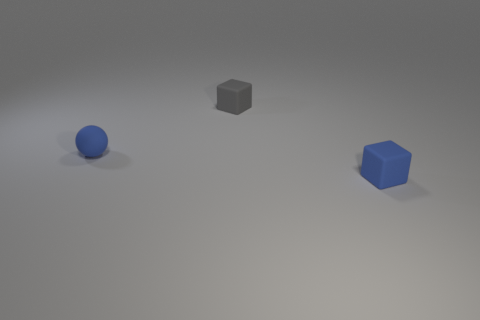Is there anything else that has the same material as the blue ball?
Your response must be concise. Yes. There is a thing that is in front of the tiny gray rubber block and on the right side of the small matte sphere; what is its material?
Give a very brief answer. Rubber. How many other gray objects are the same shape as the tiny gray thing?
Your answer should be very brief. 0. There is a sphere that is left of the block that is in front of the rubber ball; what color is it?
Make the answer very short. Blue. Are there the same number of things that are behind the small blue cube and rubber spheres?
Keep it short and to the point. No. Is there another matte thing that has the same size as the gray thing?
Keep it short and to the point. Yes. There is a blue matte block; is its size the same as the matte thing that is to the left of the small gray rubber object?
Offer a very short reply. Yes. Are there an equal number of blue balls that are in front of the small blue rubber ball and tiny things that are behind the tiny gray block?
Your answer should be compact. Yes. There is a gray cube that is on the left side of the small blue cube; what is it made of?
Your response must be concise. Rubber. Do the gray matte cube and the blue rubber cube have the same size?
Your response must be concise. Yes. 